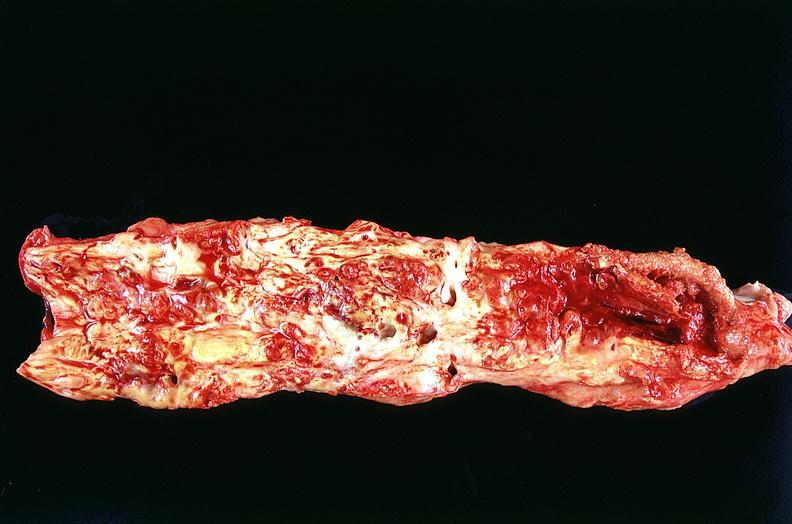what does this image show?
Answer the question using a single word or phrase. Aorta 